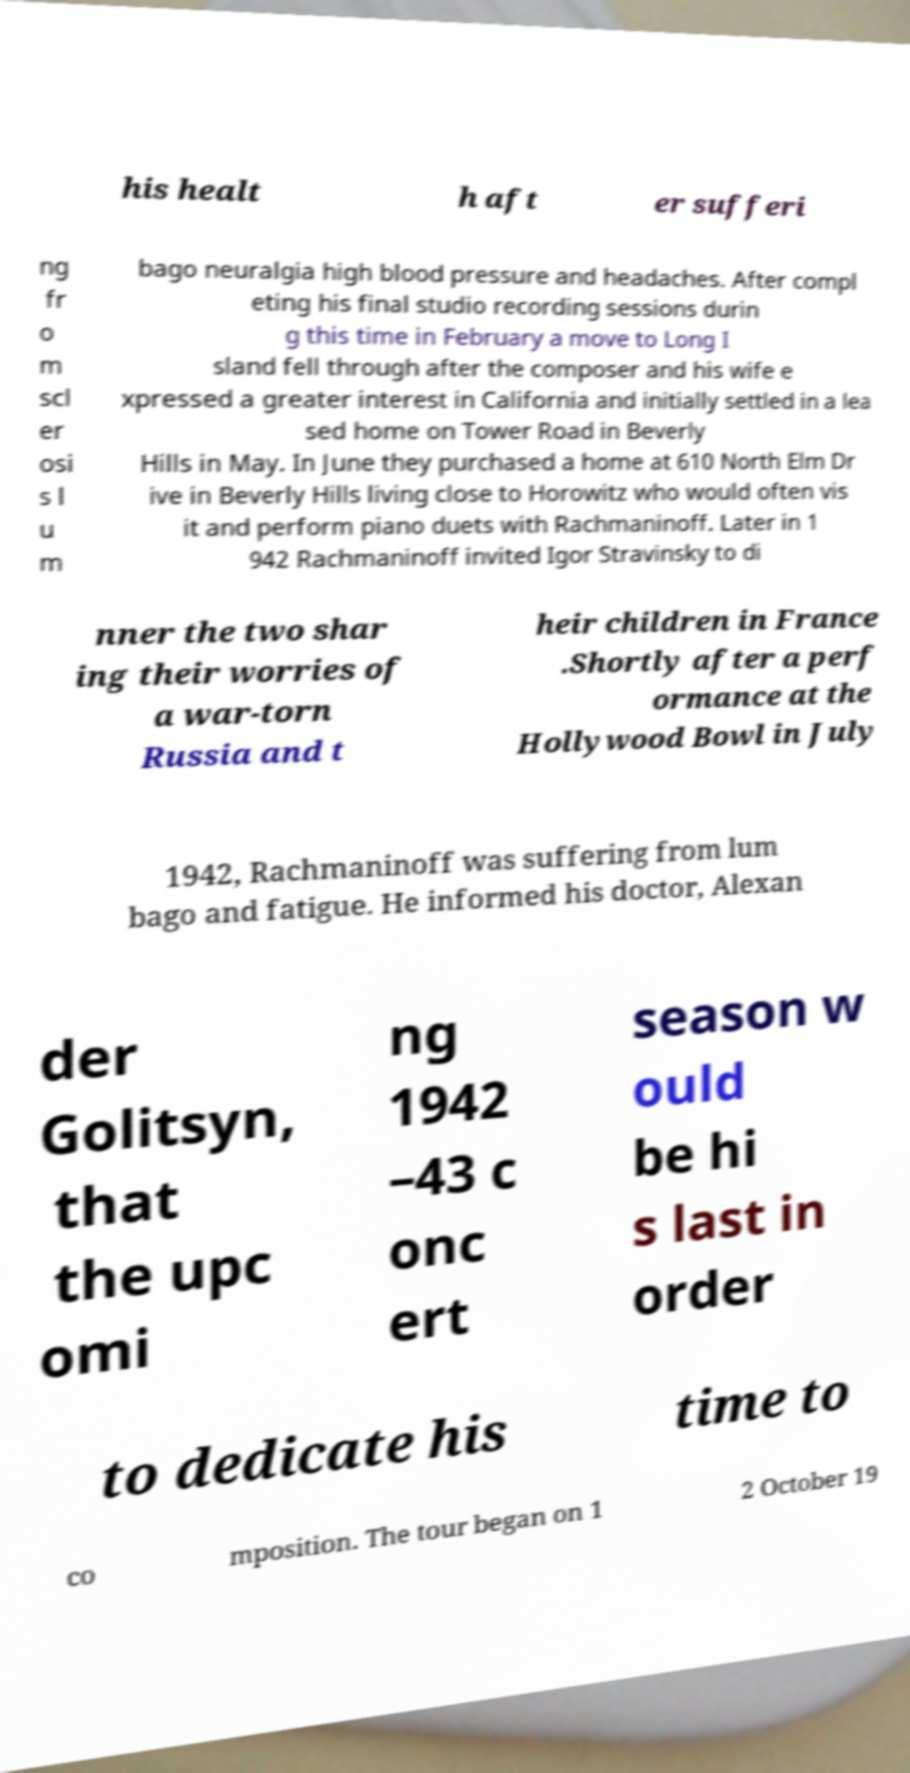There's text embedded in this image that I need extracted. Can you transcribe it verbatim? his healt h aft er sufferi ng fr o m scl er osi s l u m bago neuralgia high blood pressure and headaches. After compl eting his final studio recording sessions durin g this time in February a move to Long I sland fell through after the composer and his wife e xpressed a greater interest in California and initially settled in a lea sed home on Tower Road in Beverly Hills in May. In June they purchased a home at 610 North Elm Dr ive in Beverly Hills living close to Horowitz who would often vis it and perform piano duets with Rachmaninoff. Later in 1 942 Rachmaninoff invited Igor Stravinsky to di nner the two shar ing their worries of a war-torn Russia and t heir children in France .Shortly after a perf ormance at the Hollywood Bowl in July 1942, Rachmaninoff was suffering from lum bago and fatigue. He informed his doctor, Alexan der Golitsyn, that the upc omi ng 1942 –43 c onc ert season w ould be hi s last in order to dedicate his time to co mposition. The tour began on 1 2 October 19 